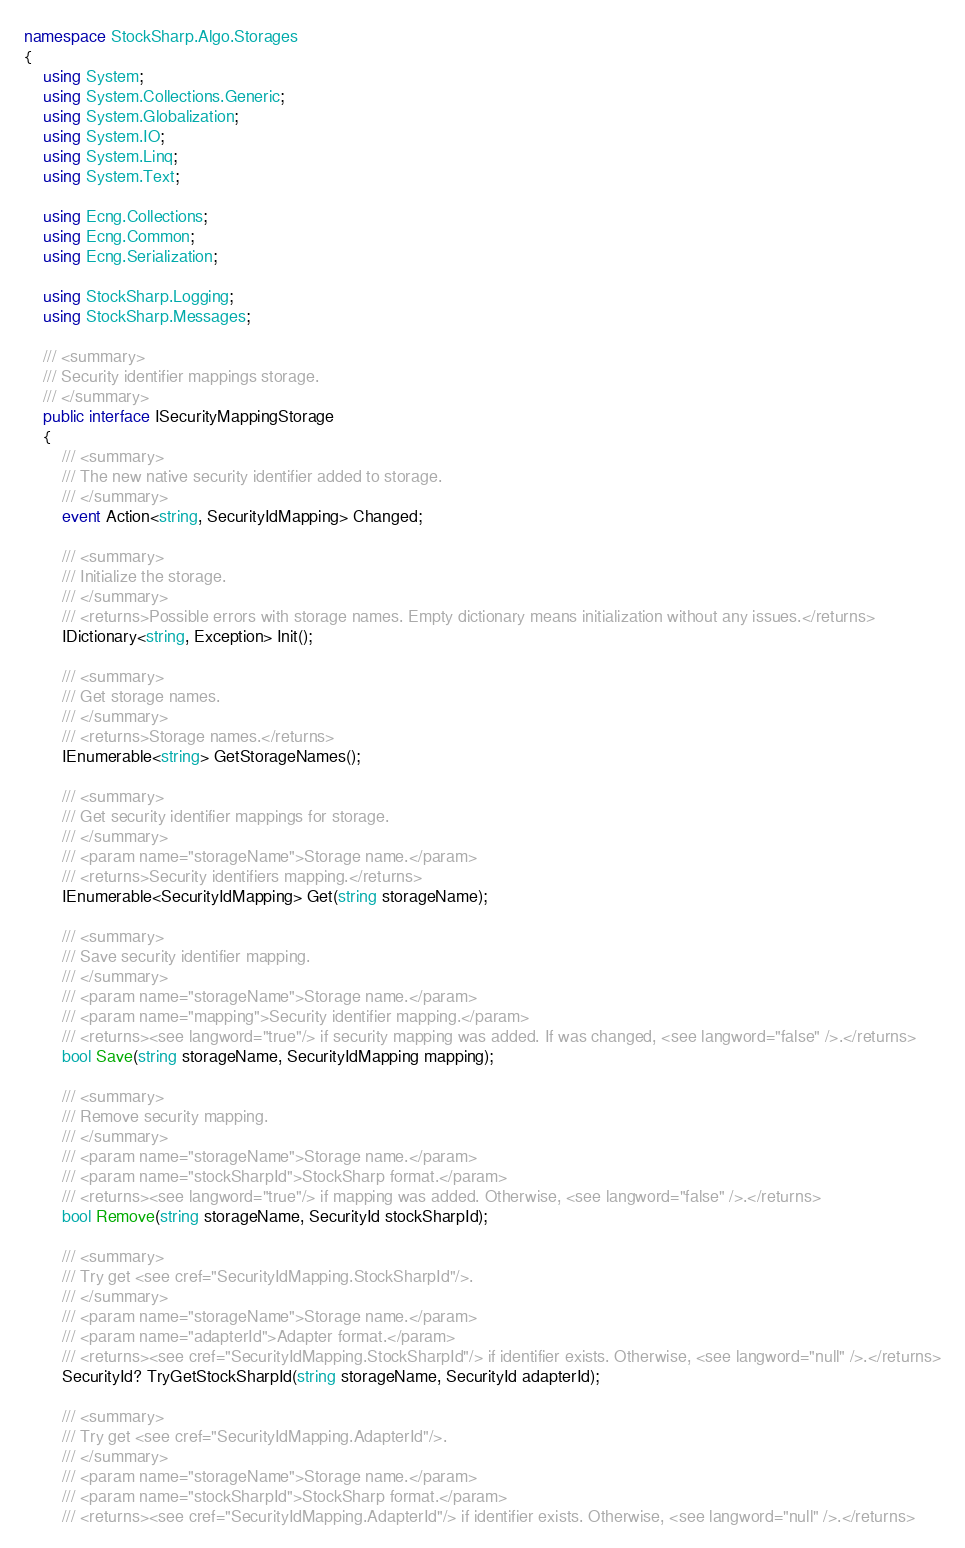Convert code to text. <code><loc_0><loc_0><loc_500><loc_500><_C#_>namespace StockSharp.Algo.Storages
{
	using System;
	using System.Collections.Generic;
	using System.Globalization;
	using System.IO;
	using System.Linq;
	using System.Text;

	using Ecng.Collections;
	using Ecng.Common;
	using Ecng.Serialization;

	using StockSharp.Logging;
	using StockSharp.Messages;

	/// <summary>
	/// Security identifier mappings storage.
	/// </summary>
	public interface ISecurityMappingStorage
	{
		/// <summary>
		/// The new native security identifier added to storage.
		/// </summary>
		event Action<string, SecurityIdMapping> Changed;

		/// <summary>
		/// Initialize the storage.
		/// </summary>
		/// <returns>Possible errors with storage names. Empty dictionary means initialization without any issues.</returns>
		IDictionary<string, Exception> Init();

		/// <summary>
		/// Get storage names.
		/// </summary>
		/// <returns>Storage names.</returns>
		IEnumerable<string> GetStorageNames();

		/// <summary>
		/// Get security identifier mappings for storage. 
		/// </summary>
		/// <param name="storageName">Storage name.</param>
		/// <returns>Security identifiers mapping.</returns>
		IEnumerable<SecurityIdMapping> Get(string storageName);

		/// <summary>
		/// Save security identifier mapping.
		/// </summary>
		/// <param name="storageName">Storage name.</param>
		/// <param name="mapping">Security identifier mapping.</param>
		/// <returns><see langword="true"/> if security mapping was added. If was changed, <see langword="false" />.</returns>
		bool Save(string storageName, SecurityIdMapping mapping);

		/// <summary>
		/// Remove security mapping.
		/// </summary>
		/// <param name="storageName">Storage name.</param>
		/// <param name="stockSharpId">StockSharp format.</param>
		/// <returns><see langword="true"/> if mapping was added. Otherwise, <see langword="false" />.</returns>
		bool Remove(string storageName, SecurityId stockSharpId);

		/// <summary>
		/// Try get <see cref="SecurityIdMapping.StockSharpId"/>.
		/// </summary>
		/// <param name="storageName">Storage name.</param>
		/// <param name="adapterId">Adapter format.</param>
		/// <returns><see cref="SecurityIdMapping.StockSharpId"/> if identifier exists. Otherwise, <see langword="null" />.</returns>
		SecurityId? TryGetStockSharpId(string storageName, SecurityId adapterId);

		/// <summary>
		/// Try get <see cref="SecurityIdMapping.AdapterId"/>.
		/// </summary>
		/// <param name="storageName">Storage name.</param>
		/// <param name="stockSharpId">StockSharp format.</param>
		/// <returns><see cref="SecurityIdMapping.AdapterId"/> if identifier exists. Otherwise, <see langword="null" />.</returns></code> 